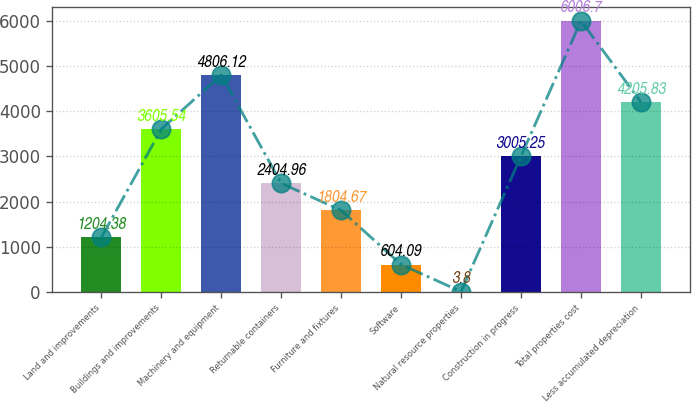Convert chart. <chart><loc_0><loc_0><loc_500><loc_500><bar_chart><fcel>Land and improvements<fcel>Buildings and improvements<fcel>Machinery and equipment<fcel>Returnable containers<fcel>Furniture and fixtures<fcel>Software<fcel>Natural resource properties<fcel>Construction in progress<fcel>Total properties cost<fcel>Less accumulated depreciation<nl><fcel>1204.38<fcel>3605.54<fcel>4806.12<fcel>2404.96<fcel>1804.67<fcel>604.09<fcel>3.8<fcel>3005.25<fcel>6006.7<fcel>4205.83<nl></chart> 